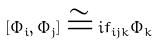Convert formula to latex. <formula><loc_0><loc_0><loc_500><loc_500>[ \Phi _ { i } , \Phi _ { j } ] \cong i f _ { i j k } \Phi _ { k }</formula> 